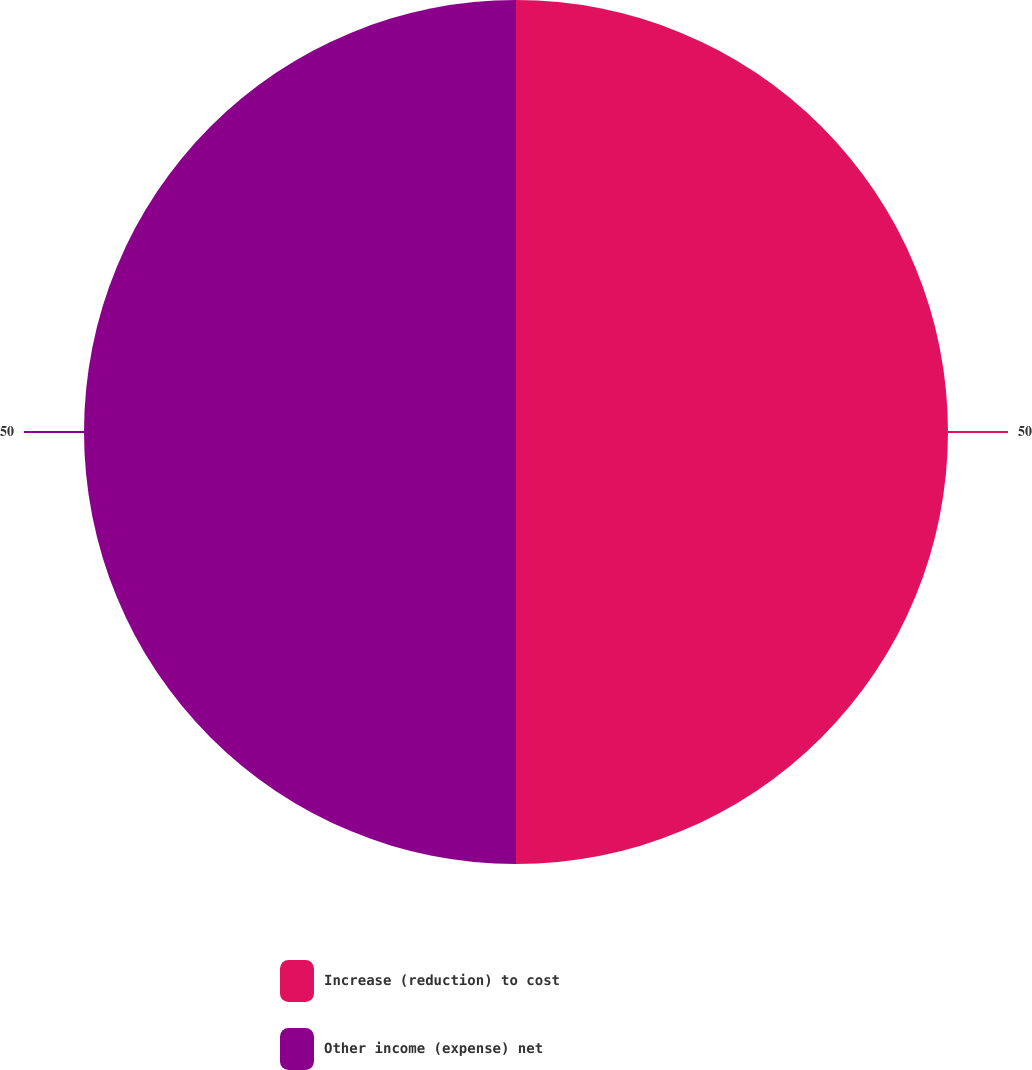Convert chart to OTSL. <chart><loc_0><loc_0><loc_500><loc_500><pie_chart><fcel>Increase (reduction) to cost<fcel>Other income (expense) net<nl><fcel>50.0%<fcel>50.0%<nl></chart> 